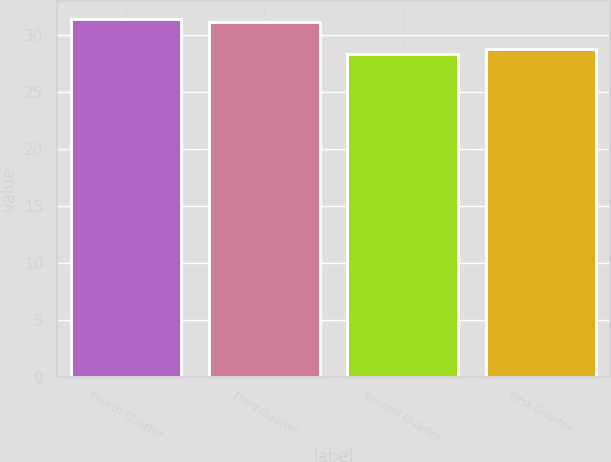Convert chart. <chart><loc_0><loc_0><loc_500><loc_500><bar_chart><fcel>Fourth Quarter<fcel>Third Quarter<fcel>Second Quarter<fcel>First Quarter<nl><fcel>31.42<fcel>31.12<fcel>28.31<fcel>28.78<nl></chart> 